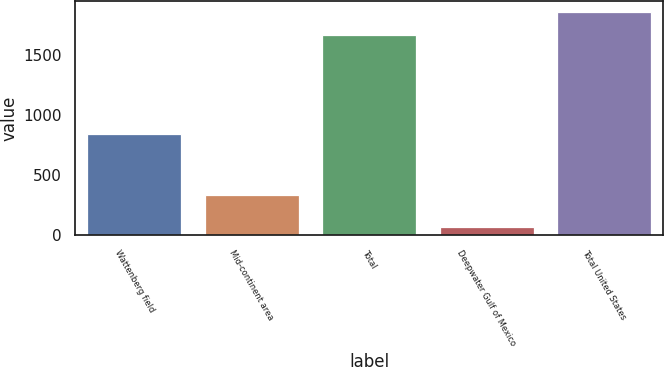Convert chart to OTSL. <chart><loc_0><loc_0><loc_500><loc_500><bar_chart><fcel>Wattenberg field<fcel>Mid-continent area<fcel>Total<fcel>Deepwater Gulf of Mexico<fcel>Total United States<nl><fcel>842<fcel>336<fcel>1672<fcel>64<fcel>1859<nl></chart> 